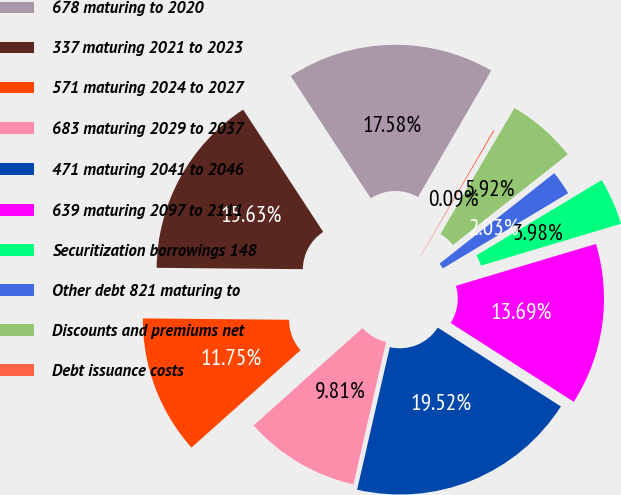Convert chart to OTSL. <chart><loc_0><loc_0><loc_500><loc_500><pie_chart><fcel>678 maturing to 2020<fcel>337 maturing 2021 to 2023<fcel>571 maturing 2024 to 2027<fcel>683 maturing 2029 to 2037<fcel>471 maturing 2041 to 2046<fcel>639 maturing 2097 to 2111<fcel>Securitization borrowings 148<fcel>Other debt 821 maturing to<fcel>Discounts and premiums net<fcel>Debt issuance costs<nl><fcel>17.58%<fcel>15.63%<fcel>11.75%<fcel>9.81%<fcel>19.52%<fcel>13.69%<fcel>3.98%<fcel>2.03%<fcel>5.92%<fcel>0.09%<nl></chart> 